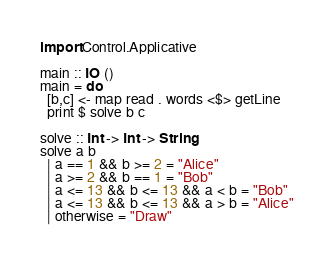Convert code to text. <code><loc_0><loc_0><loc_500><loc_500><_Haskell_>import Control.Applicative

main :: IO ()
main = do
  [b,c] <- map read . words <$> getLine
  print $ solve b c

solve :: Int -> Int -> String
solve a b
  | a == 1 && b >= 2 = "Alice"
  | a >= 2 && b == 1 = "Bob"
  | a <= 13 && b <= 13 && a < b = "Bob"
  | a <= 13 && b <= 13 && a > b = "Alice"
  | otherwise = "Draw"</code> 